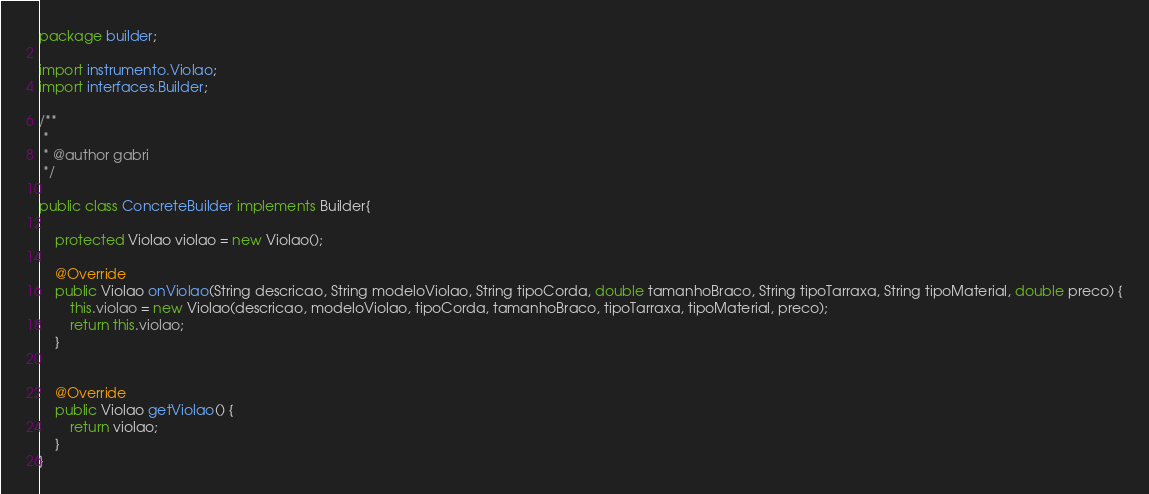<code> <loc_0><loc_0><loc_500><loc_500><_Java_>
package builder;

import instrumento.Violao;
import interfaces.Builder;

/**
 *
 * @author gabri
 */

public class ConcreteBuilder implements Builder{

    protected Violao violao = new Violao();
    
    @Override
    public Violao onViolao(String descricao, String modeloViolao, String tipoCorda, double tamanhoBraco, String tipoTarraxa, String tipoMaterial, double preco) {
        this.violao = new Violao(descricao, modeloViolao, tipoCorda, tamanhoBraco, tipoTarraxa, tipoMaterial, preco);
        return this.violao;
    }

    
    @Override
    public Violao getViolao() {
        return violao;
    }
}
</code> 